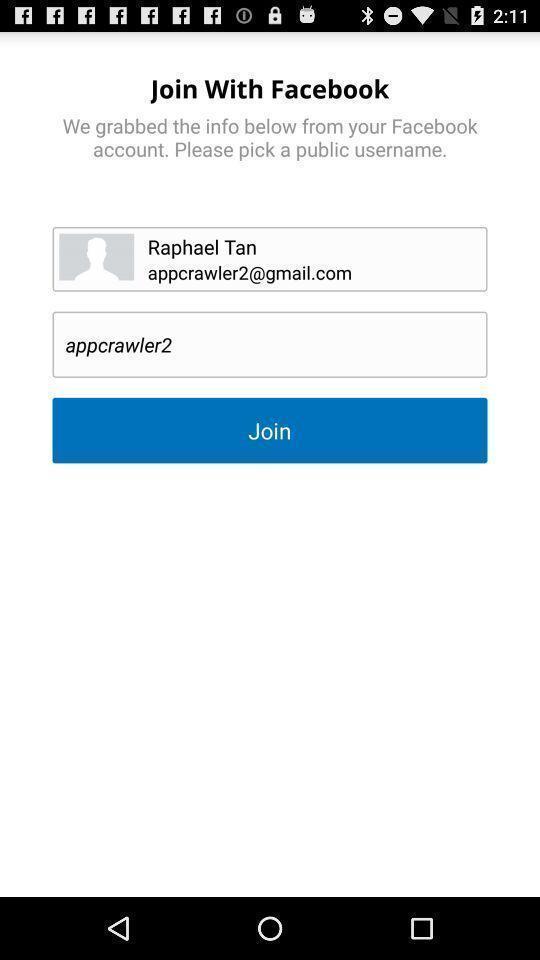Tell me what you see in this picture. Sign in page. 